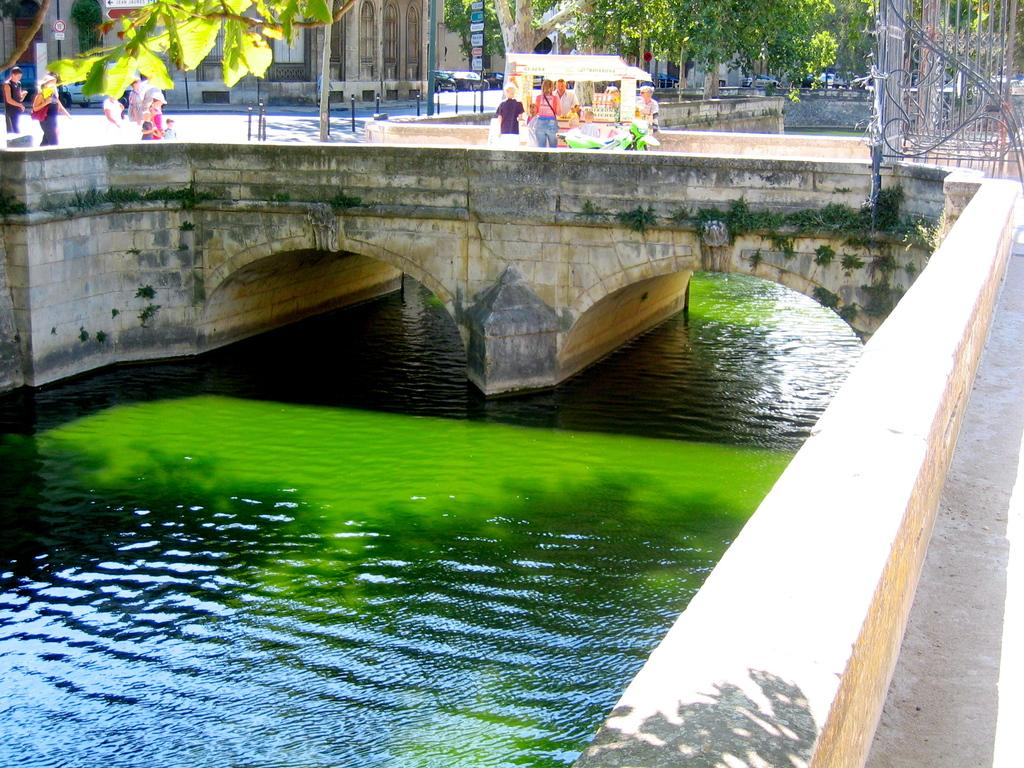What type of structure can be seen in the image? There is a bridge in the image. Are there any people visible in the image? Yes, there are persons in the image. What type of establishment can be seen in the image? There is a shop in the image. What is one object that can be seen in the image? There is a pole in the image. What type of material is present in the image? There are boards in the image. What type of natural element is present in the image? There are trees in the image. What type of signage is present in the image? There are sign boards in the image. What type of man-made structures are present in the image? There are buildings in the image. Can you tell me how many twigs are being balanced on the bridge in the image? There are no twigs present in the image, and therefore no such activity can be observed. What type of game are the persons playing in the image? There is no indication of a game being played in the image. 